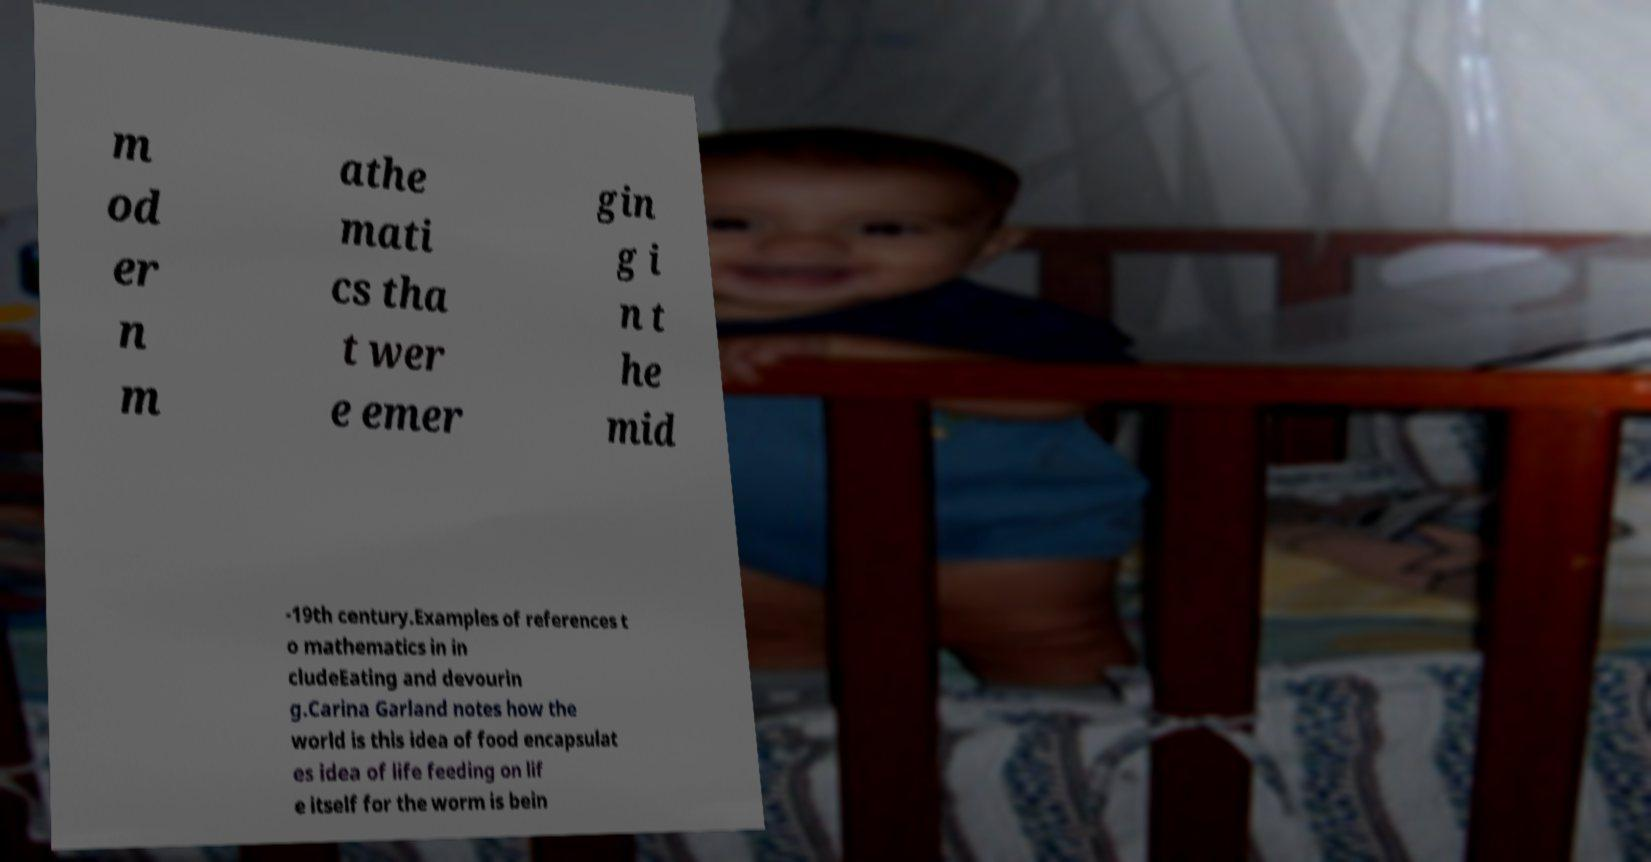What messages or text are displayed in this image? I need them in a readable, typed format. m od er n m athe mati cs tha t wer e emer gin g i n t he mid -19th century.Examples of references t o mathematics in in cludeEating and devourin g.Carina Garland notes how the world is this idea of food encapsulat es idea of life feeding on lif e itself for the worm is bein 